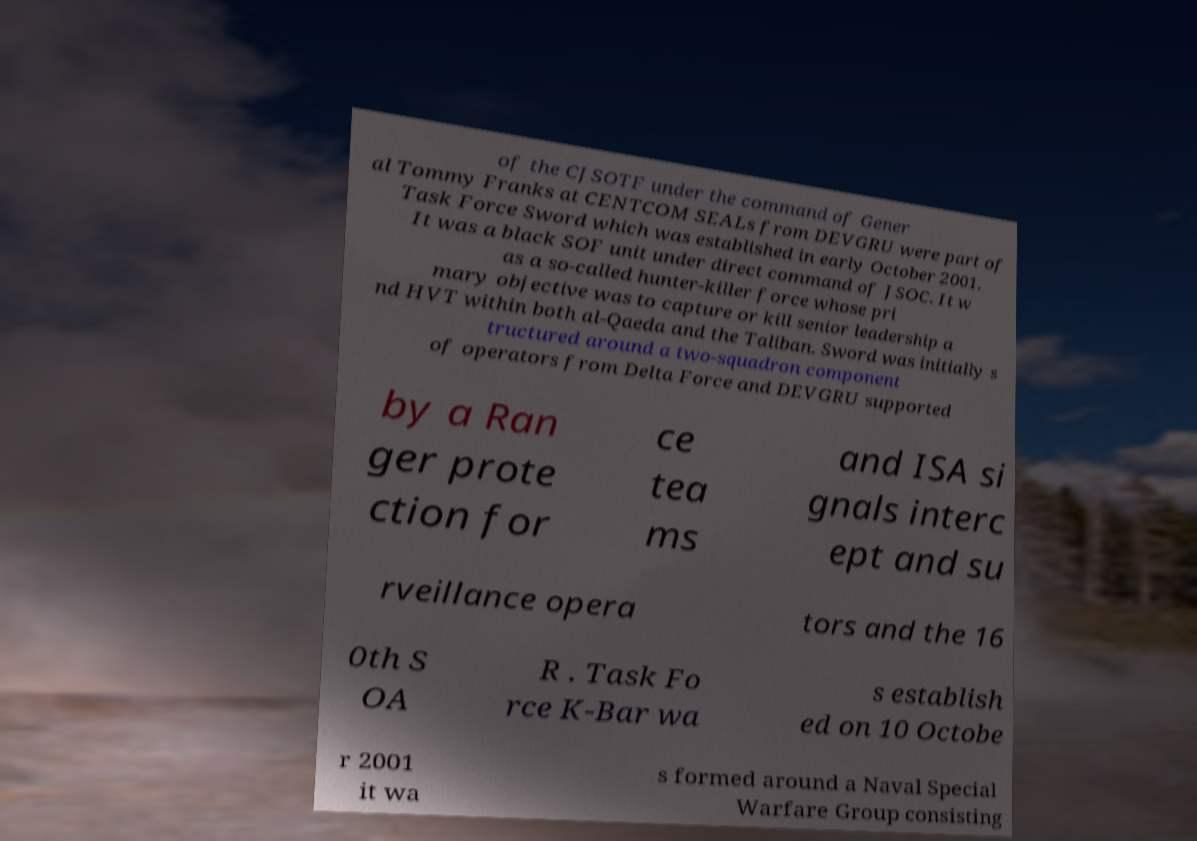There's text embedded in this image that I need extracted. Can you transcribe it verbatim? of the CJSOTF under the command of Gener al Tommy Franks at CENTCOM SEALs from DEVGRU were part of Task Force Sword which was established in early October 2001. It was a black SOF unit under direct command of JSOC. It w as a so-called hunter-killer force whose pri mary objective was to capture or kill senior leadership a nd HVT within both al-Qaeda and the Taliban. Sword was initially s tructured around a two-squadron component of operators from Delta Force and DEVGRU supported by a Ran ger prote ction for ce tea ms and ISA si gnals interc ept and su rveillance opera tors and the 16 0th S OA R . Task Fo rce K-Bar wa s establish ed on 10 Octobe r 2001 it wa s formed around a Naval Special Warfare Group consisting 